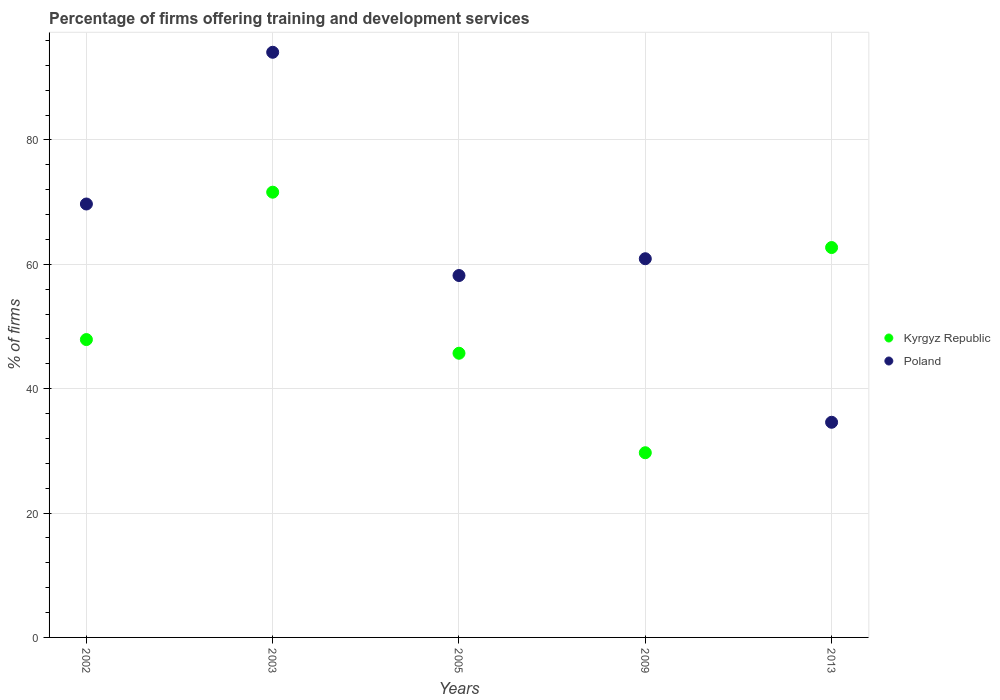How many different coloured dotlines are there?
Keep it short and to the point. 2. What is the percentage of firms offering training and development in Poland in 2013?
Make the answer very short. 34.6. Across all years, what is the maximum percentage of firms offering training and development in Kyrgyz Republic?
Offer a very short reply. 71.6. Across all years, what is the minimum percentage of firms offering training and development in Poland?
Your answer should be very brief. 34.6. What is the total percentage of firms offering training and development in Kyrgyz Republic in the graph?
Provide a short and direct response. 257.6. What is the difference between the percentage of firms offering training and development in Poland in 2005 and that in 2009?
Offer a terse response. -2.7. What is the difference between the percentage of firms offering training and development in Kyrgyz Republic in 2013 and the percentage of firms offering training and development in Poland in 2003?
Provide a short and direct response. -31.4. What is the average percentage of firms offering training and development in Kyrgyz Republic per year?
Keep it short and to the point. 51.52. What is the ratio of the percentage of firms offering training and development in Poland in 2002 to that in 2009?
Provide a short and direct response. 1.14. Is the difference between the percentage of firms offering training and development in Kyrgyz Republic in 2002 and 2005 greater than the difference between the percentage of firms offering training and development in Poland in 2002 and 2005?
Offer a terse response. No. What is the difference between the highest and the second highest percentage of firms offering training and development in Poland?
Keep it short and to the point. 24.4. What is the difference between the highest and the lowest percentage of firms offering training and development in Poland?
Keep it short and to the point. 59.5. Is the sum of the percentage of firms offering training and development in Poland in 2009 and 2013 greater than the maximum percentage of firms offering training and development in Kyrgyz Republic across all years?
Keep it short and to the point. Yes. How many dotlines are there?
Provide a succinct answer. 2. How many years are there in the graph?
Ensure brevity in your answer.  5. Does the graph contain any zero values?
Your answer should be compact. No. Does the graph contain grids?
Your answer should be very brief. Yes. Where does the legend appear in the graph?
Offer a terse response. Center right. How many legend labels are there?
Give a very brief answer. 2. How are the legend labels stacked?
Your answer should be very brief. Vertical. What is the title of the graph?
Ensure brevity in your answer.  Percentage of firms offering training and development services. Does "Canada" appear as one of the legend labels in the graph?
Provide a succinct answer. No. What is the label or title of the Y-axis?
Ensure brevity in your answer.  % of firms. What is the % of firms in Kyrgyz Republic in 2002?
Make the answer very short. 47.9. What is the % of firms of Poland in 2002?
Provide a succinct answer. 69.7. What is the % of firms of Kyrgyz Republic in 2003?
Your answer should be compact. 71.6. What is the % of firms in Poland in 2003?
Give a very brief answer. 94.1. What is the % of firms in Kyrgyz Republic in 2005?
Keep it short and to the point. 45.7. What is the % of firms in Poland in 2005?
Make the answer very short. 58.2. What is the % of firms in Kyrgyz Republic in 2009?
Make the answer very short. 29.7. What is the % of firms in Poland in 2009?
Provide a short and direct response. 60.9. What is the % of firms of Kyrgyz Republic in 2013?
Make the answer very short. 62.7. What is the % of firms in Poland in 2013?
Offer a terse response. 34.6. Across all years, what is the maximum % of firms of Kyrgyz Republic?
Give a very brief answer. 71.6. Across all years, what is the maximum % of firms in Poland?
Your response must be concise. 94.1. Across all years, what is the minimum % of firms of Kyrgyz Republic?
Make the answer very short. 29.7. Across all years, what is the minimum % of firms in Poland?
Offer a terse response. 34.6. What is the total % of firms in Kyrgyz Republic in the graph?
Ensure brevity in your answer.  257.6. What is the total % of firms in Poland in the graph?
Keep it short and to the point. 317.5. What is the difference between the % of firms of Kyrgyz Republic in 2002 and that in 2003?
Keep it short and to the point. -23.7. What is the difference between the % of firms of Poland in 2002 and that in 2003?
Offer a terse response. -24.4. What is the difference between the % of firms in Kyrgyz Republic in 2002 and that in 2013?
Your answer should be compact. -14.8. What is the difference between the % of firms in Poland in 2002 and that in 2013?
Offer a very short reply. 35.1. What is the difference between the % of firms of Kyrgyz Republic in 2003 and that in 2005?
Provide a short and direct response. 25.9. What is the difference between the % of firms of Poland in 2003 and that in 2005?
Keep it short and to the point. 35.9. What is the difference between the % of firms of Kyrgyz Republic in 2003 and that in 2009?
Provide a succinct answer. 41.9. What is the difference between the % of firms in Poland in 2003 and that in 2009?
Provide a succinct answer. 33.2. What is the difference between the % of firms in Poland in 2003 and that in 2013?
Your answer should be compact. 59.5. What is the difference between the % of firms of Poland in 2005 and that in 2009?
Offer a terse response. -2.7. What is the difference between the % of firms of Kyrgyz Republic in 2005 and that in 2013?
Ensure brevity in your answer.  -17. What is the difference between the % of firms of Poland in 2005 and that in 2013?
Your answer should be compact. 23.6. What is the difference between the % of firms in Kyrgyz Republic in 2009 and that in 2013?
Ensure brevity in your answer.  -33. What is the difference between the % of firms of Poland in 2009 and that in 2013?
Your answer should be compact. 26.3. What is the difference between the % of firms of Kyrgyz Republic in 2002 and the % of firms of Poland in 2003?
Your response must be concise. -46.2. What is the difference between the % of firms in Kyrgyz Republic in 2002 and the % of firms in Poland in 2009?
Provide a succinct answer. -13. What is the difference between the % of firms in Kyrgyz Republic in 2002 and the % of firms in Poland in 2013?
Offer a very short reply. 13.3. What is the difference between the % of firms of Kyrgyz Republic in 2003 and the % of firms of Poland in 2005?
Offer a terse response. 13.4. What is the difference between the % of firms of Kyrgyz Republic in 2003 and the % of firms of Poland in 2013?
Your answer should be very brief. 37. What is the difference between the % of firms of Kyrgyz Republic in 2005 and the % of firms of Poland in 2009?
Offer a very short reply. -15.2. What is the difference between the % of firms of Kyrgyz Republic in 2005 and the % of firms of Poland in 2013?
Make the answer very short. 11.1. What is the average % of firms in Kyrgyz Republic per year?
Provide a succinct answer. 51.52. What is the average % of firms of Poland per year?
Make the answer very short. 63.5. In the year 2002, what is the difference between the % of firms in Kyrgyz Republic and % of firms in Poland?
Provide a succinct answer. -21.8. In the year 2003, what is the difference between the % of firms of Kyrgyz Republic and % of firms of Poland?
Make the answer very short. -22.5. In the year 2009, what is the difference between the % of firms of Kyrgyz Republic and % of firms of Poland?
Ensure brevity in your answer.  -31.2. In the year 2013, what is the difference between the % of firms of Kyrgyz Republic and % of firms of Poland?
Make the answer very short. 28.1. What is the ratio of the % of firms in Kyrgyz Republic in 2002 to that in 2003?
Your answer should be compact. 0.67. What is the ratio of the % of firms in Poland in 2002 to that in 2003?
Your answer should be compact. 0.74. What is the ratio of the % of firms of Kyrgyz Republic in 2002 to that in 2005?
Provide a succinct answer. 1.05. What is the ratio of the % of firms of Poland in 2002 to that in 2005?
Provide a short and direct response. 1.2. What is the ratio of the % of firms in Kyrgyz Republic in 2002 to that in 2009?
Provide a succinct answer. 1.61. What is the ratio of the % of firms of Poland in 2002 to that in 2009?
Give a very brief answer. 1.14. What is the ratio of the % of firms of Kyrgyz Republic in 2002 to that in 2013?
Give a very brief answer. 0.76. What is the ratio of the % of firms of Poland in 2002 to that in 2013?
Offer a terse response. 2.01. What is the ratio of the % of firms in Kyrgyz Republic in 2003 to that in 2005?
Provide a short and direct response. 1.57. What is the ratio of the % of firms of Poland in 2003 to that in 2005?
Offer a very short reply. 1.62. What is the ratio of the % of firms of Kyrgyz Republic in 2003 to that in 2009?
Offer a terse response. 2.41. What is the ratio of the % of firms in Poland in 2003 to that in 2009?
Ensure brevity in your answer.  1.55. What is the ratio of the % of firms of Kyrgyz Republic in 2003 to that in 2013?
Your response must be concise. 1.14. What is the ratio of the % of firms in Poland in 2003 to that in 2013?
Your answer should be very brief. 2.72. What is the ratio of the % of firms of Kyrgyz Republic in 2005 to that in 2009?
Give a very brief answer. 1.54. What is the ratio of the % of firms of Poland in 2005 to that in 2009?
Make the answer very short. 0.96. What is the ratio of the % of firms in Kyrgyz Republic in 2005 to that in 2013?
Offer a terse response. 0.73. What is the ratio of the % of firms in Poland in 2005 to that in 2013?
Provide a succinct answer. 1.68. What is the ratio of the % of firms in Kyrgyz Republic in 2009 to that in 2013?
Provide a short and direct response. 0.47. What is the ratio of the % of firms of Poland in 2009 to that in 2013?
Provide a short and direct response. 1.76. What is the difference between the highest and the second highest % of firms of Kyrgyz Republic?
Your answer should be compact. 8.9. What is the difference between the highest and the second highest % of firms of Poland?
Offer a terse response. 24.4. What is the difference between the highest and the lowest % of firms in Kyrgyz Republic?
Your response must be concise. 41.9. What is the difference between the highest and the lowest % of firms in Poland?
Your answer should be very brief. 59.5. 